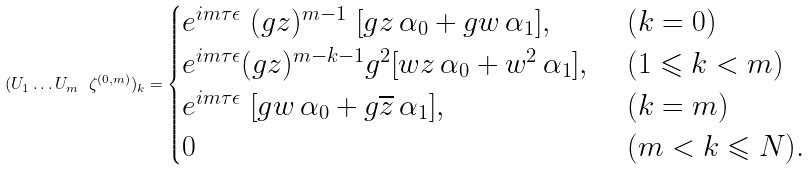Convert formula to latex. <formula><loc_0><loc_0><loc_500><loc_500>( U _ { 1 } \dots U _ { m } \ \zeta ^ { ( 0 , m ) } ) _ { k } = \begin{cases} e ^ { i m \tau \epsilon } \ ( g { z } ) ^ { m - 1 } \ [ g { z } \, \alpha _ { 0 } + g w \, \alpha _ { 1 } ] , \ & ( k = 0 ) \\ e ^ { i m \tau \epsilon } ( g { z } ) ^ { m - k - 1 } g ^ { 2 } [ w z \, \alpha _ { 0 } + w ^ { 2 } \, \alpha _ { 1 } ] , \ & ( 1 \leqslant k < m ) \\ e ^ { i m \tau \epsilon } \ [ g w \, \alpha _ { 0 } + g \overline { z } \, \alpha _ { 1 } ] , \ & ( k = m ) \\ 0 \ & ( m < k \leqslant N ) . \end{cases}</formula> 